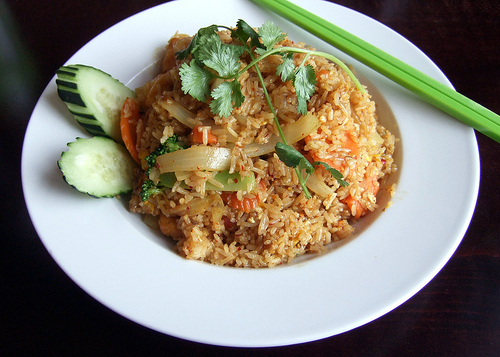<image>
Is the chopsticks on the bowl? Yes. Looking at the image, I can see the chopsticks is positioned on top of the bowl, with the bowl providing support. Is there a chop sticks in front of the rice? No. The chop sticks is not in front of the rice. The spatial positioning shows a different relationship between these objects. 